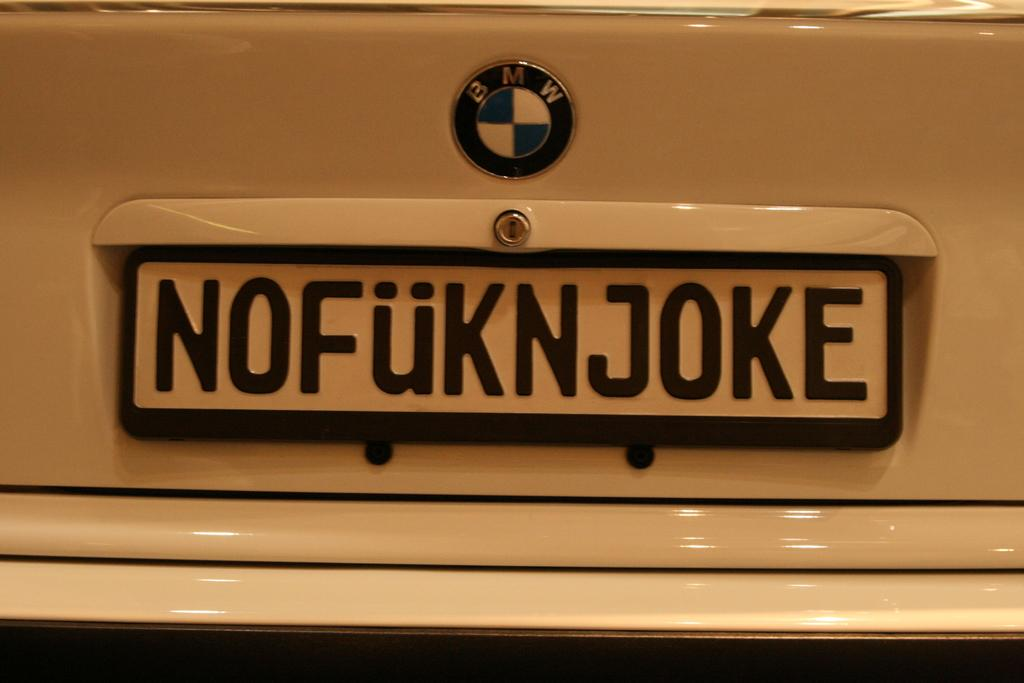What is the main subject of the image? There is a vehicle in the image. How is the vehicle depicted in the image? The vehicle appears to be truncated. What else can be seen in the image besides the vehicle? There is a logo and a board in the image. What type of flowers can be seen growing on the floor in the image? There is no floor or flowers present in the image; it features a vehicle that appears to be truncated, along with a logo and a board. 